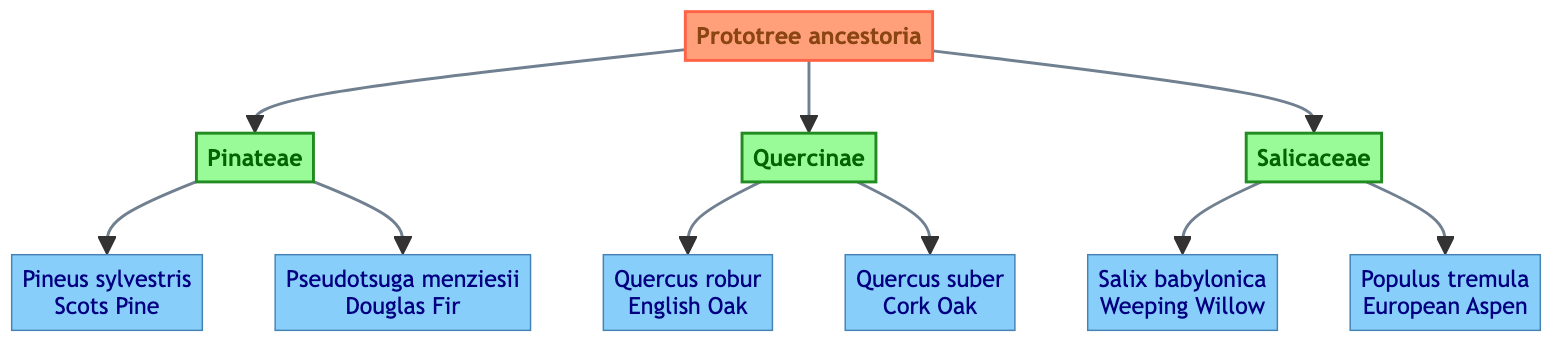What is the common name of the species represented by "Salix babylonica"? The species "Salix babylonica" is connected to the node that represents "Weeping Willow." Therefore, the common name of the species is "Weeping Willow."
Answer: Weeping Willow How many branches descend from "Prototree ancestoria"? The diagram shows three branches descending from "Prototree ancestoria," which are "Pinateae," "Quercinae," and "Salicaceae." Thus, the total number of branches is three.
Answer: 3 Which species is noted for rapid regrowth and soil stabilization? Looking at the "Salicaceae" branch, "Populus tremula" is listed, and its characteristics state that it is notable for rapid regrowth and soil stabilization.
Answer: Populus tremula What is the primary characteristic of "Quercus suber"? The characteristics of "Quercus suber," as listed in the diagram, highlight its proficiency at surviving in fire-damaged ecosystems. Therefore, the primary characteristic is its fire survival capability.
Answer: Proficient at surviving in fire-damaged ecosystems Which species comes after "Pseudotsuga menziesii"? In the diagram, "Pseudotsuga menziesii" is the second species listed under the "Pinateae" branch, and it does not have any other species following it. Hence, there is no species that comes after it in this context.
Answer: None 